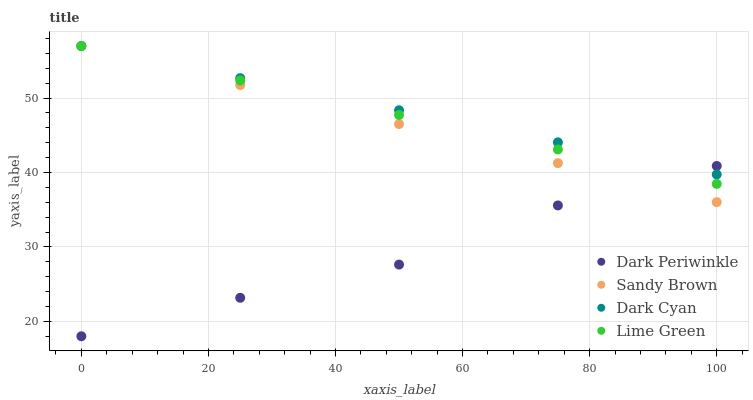Does Dark Periwinkle have the minimum area under the curve?
Answer yes or no. Yes. Does Dark Cyan have the maximum area under the curve?
Answer yes or no. Yes. Does Lime Green have the minimum area under the curve?
Answer yes or no. No. Does Lime Green have the maximum area under the curve?
Answer yes or no. No. Is Dark Cyan the smoothest?
Answer yes or no. Yes. Is Dark Periwinkle the roughest?
Answer yes or no. Yes. Is Lime Green the smoothest?
Answer yes or no. No. Is Lime Green the roughest?
Answer yes or no. No. Does Dark Periwinkle have the lowest value?
Answer yes or no. Yes. Does Lime Green have the lowest value?
Answer yes or no. No. Does Sandy Brown have the highest value?
Answer yes or no. Yes. Does Dark Periwinkle have the highest value?
Answer yes or no. No. Does Dark Periwinkle intersect Lime Green?
Answer yes or no. Yes. Is Dark Periwinkle less than Lime Green?
Answer yes or no. No. Is Dark Periwinkle greater than Lime Green?
Answer yes or no. No. 